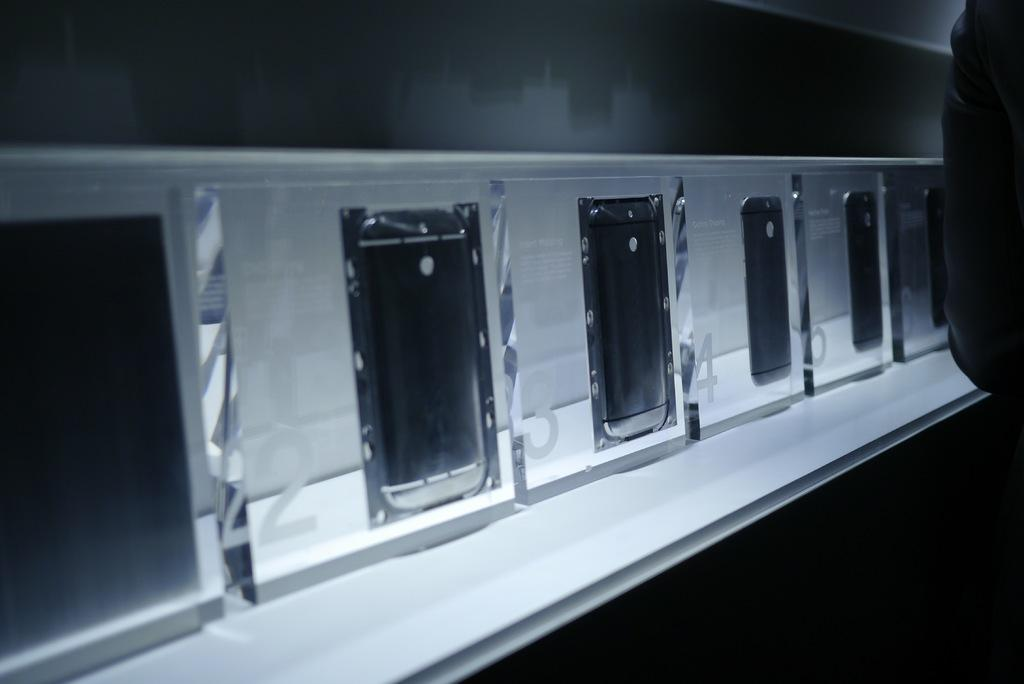<image>
Create a compact narrative representing the image presented. The windows are numbered 22, 23, 24, 25, and so on. 